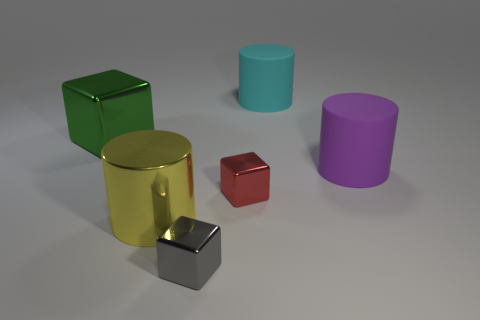Subtract all small gray cubes. How many cubes are left? 2 Add 2 green blocks. How many objects exist? 8 Subtract 1 cyan cylinders. How many objects are left? 5 Subtract all brown blocks. Subtract all yellow cylinders. How many blocks are left? 3 Subtract all tiny gray metallic blocks. Subtract all red shiny objects. How many objects are left? 4 Add 2 large yellow shiny things. How many large yellow shiny things are left? 3 Add 2 small gray shiny blocks. How many small gray shiny blocks exist? 3 